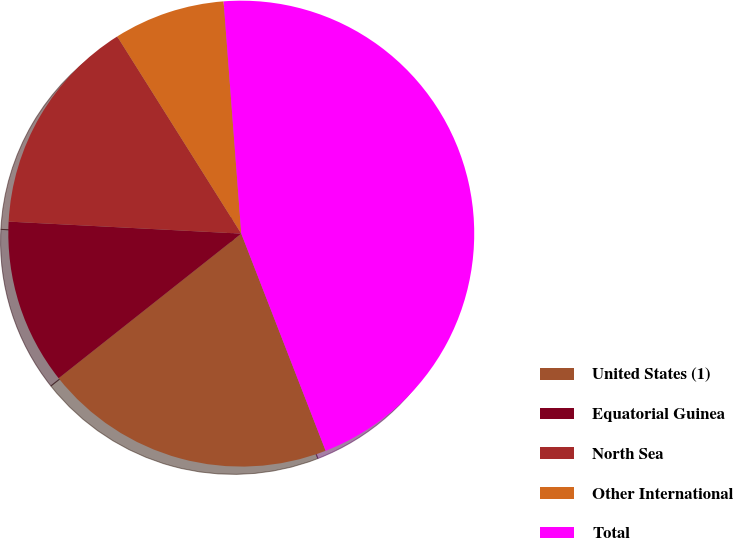Convert chart to OTSL. <chart><loc_0><loc_0><loc_500><loc_500><pie_chart><fcel>United States (1)<fcel>Equatorial Guinea<fcel>North Sea<fcel>Other International<fcel>Total<nl><fcel>20.24%<fcel>11.48%<fcel>15.24%<fcel>7.73%<fcel>45.31%<nl></chart> 